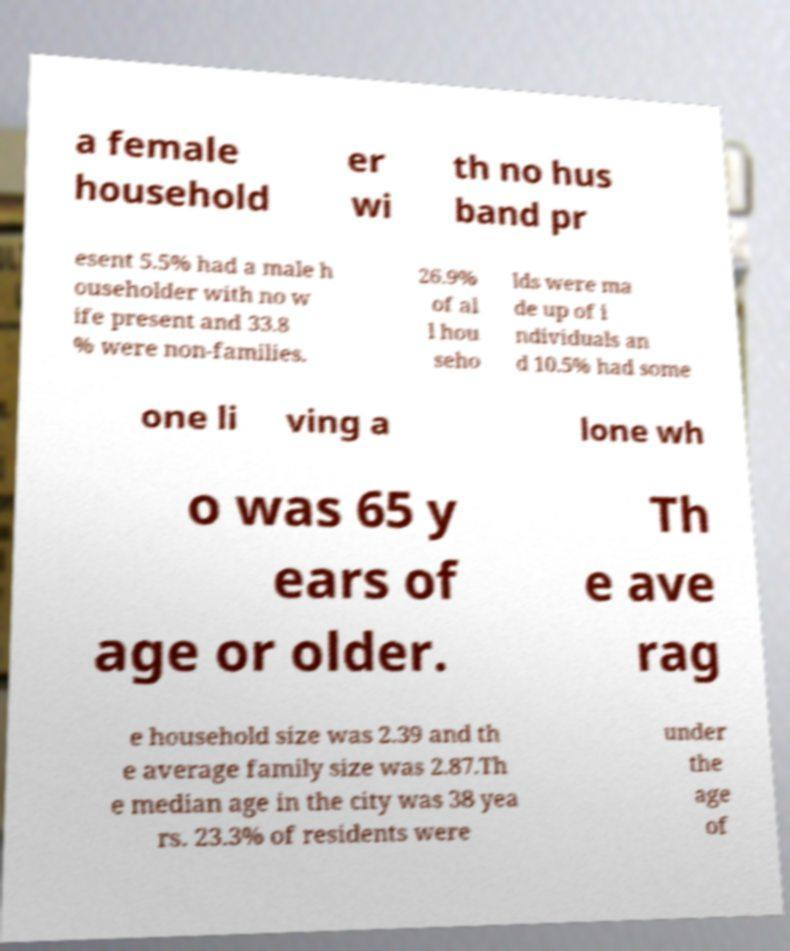For documentation purposes, I need the text within this image transcribed. Could you provide that? a female household er wi th no hus band pr esent 5.5% had a male h ouseholder with no w ife present and 33.8 % were non-families. 26.9% of al l hou seho lds were ma de up of i ndividuals an d 10.5% had some one li ving a lone wh o was 65 y ears of age or older. Th e ave rag e household size was 2.39 and th e average family size was 2.87.Th e median age in the city was 38 yea rs. 23.3% of residents were under the age of 